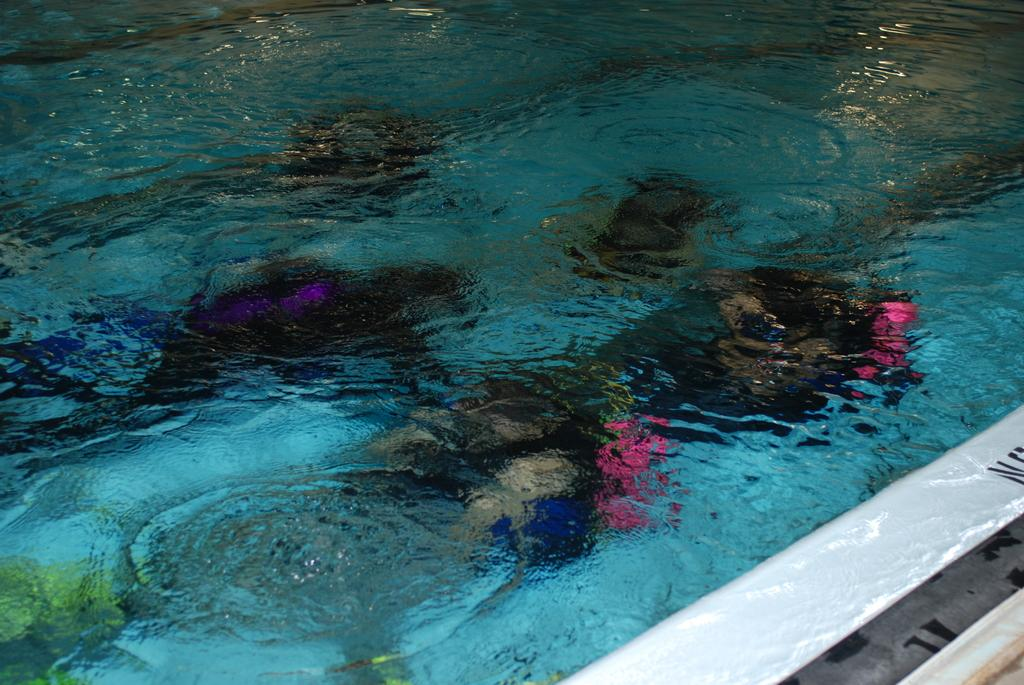What is visible in the image? Water is visible in the image. What are the persons in the image doing? The persons are in the water. What color are the dresses worn by the persons in the image? The persons are wearing black color dresses. How many pigs are swimming with the persons in the image? There are no pigs present in the image. What type of society do the persons in the image belong to? The provided facts do not give any information about the society the persons in the image belong to. 